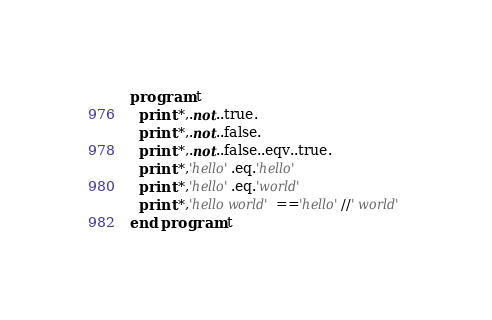<code> <loc_0><loc_0><loc_500><loc_500><_FORTRAN_>program t
  print *,.not..true.
  print *,.not..false.
  print *,.not..false..eqv..true.
  print *,'hello'.eq.'hello'
  print *,'hello'.eq.'world'
  print *,'hello world'=='hello'//' world'
end program t
</code> 